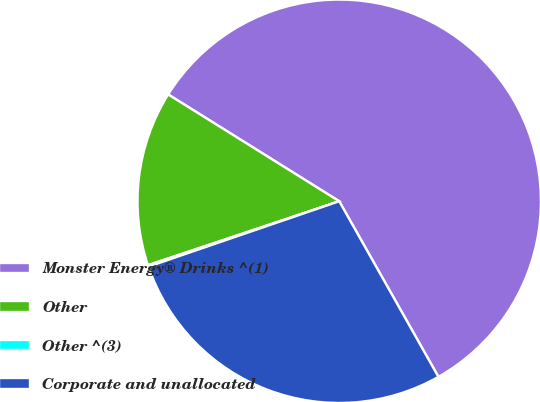Convert chart to OTSL. <chart><loc_0><loc_0><loc_500><loc_500><pie_chart><fcel>Monster Energy® Drinks ^(1)<fcel>Other<fcel>Other ^(3)<fcel>Corporate and unallocated<nl><fcel>57.93%<fcel>14.02%<fcel>0.12%<fcel>27.93%<nl></chart> 